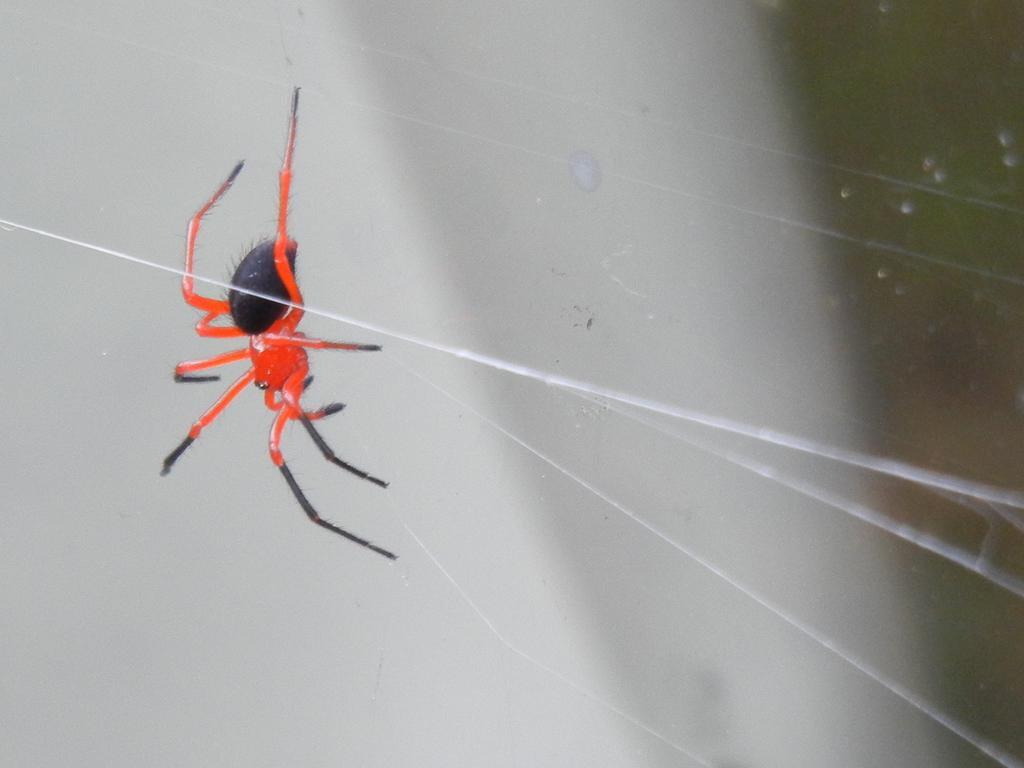What type of creature is present in the image? There is an insect in the image. What color is the insect? The insect is orange in color. Can you describe the background of the image? The background of the image is blurry. How does the insect participate in the argument in the image? There is no argument present in the image, and insects do not have the ability to participate in arguments. 